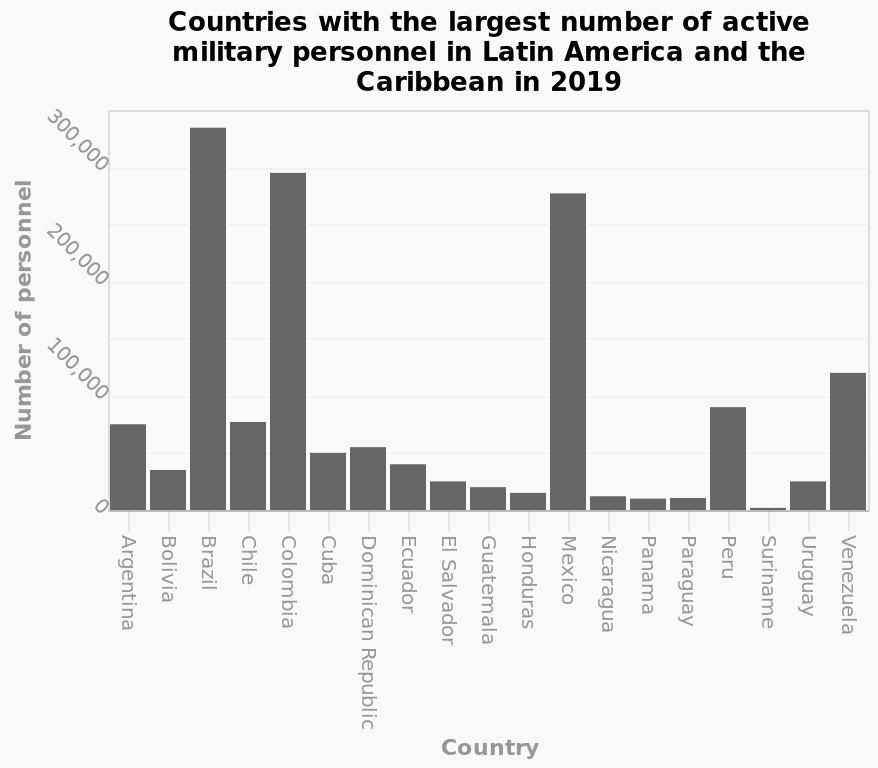<image>
Can you provide the names of the three countries with a significantly higher number of military personnel?  Unfortunately, the description does not provide the names of the three countries. Which country is labeled last on the x-axis?  Venezuela is the last country labeled on the x-axis. Which countries have an exponentially larger number of military personnel compared to all other countries?  The three countries with an exponentially larger number of military personnel compared to all others are not named in the description. 